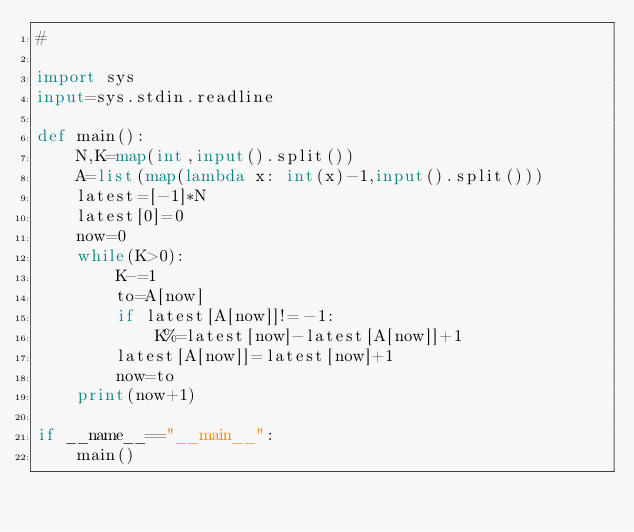<code> <loc_0><loc_0><loc_500><loc_500><_Python_>#

import sys
input=sys.stdin.readline

def main():
    N,K=map(int,input().split())
    A=list(map(lambda x: int(x)-1,input().split()))
    latest=[-1]*N
    latest[0]=0
    now=0
    while(K>0):
        K-=1
        to=A[now]
        if latest[A[now]]!=-1:
            K%=latest[now]-latest[A[now]]+1
        latest[A[now]]=latest[now]+1
        now=to
    print(now+1)
        
if __name__=="__main__":
    main()
</code> 